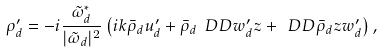Convert formula to latex. <formula><loc_0><loc_0><loc_500><loc_500>\rho ^ { \prime } _ { d } = - i \frac { \tilde { \omega } ^ { * } _ { d } } { | \tilde { \omega } _ { d } | ^ { 2 } } \left ( i k \bar { \rho } _ { d } u ^ { \prime } _ { d } + \bar { \rho } _ { d } \ D D { w ^ { \prime } _ { d } } { z } + \ D D { \bar { \rho } _ { d } } { z } w ^ { \prime } _ { d } \right ) ,</formula> 